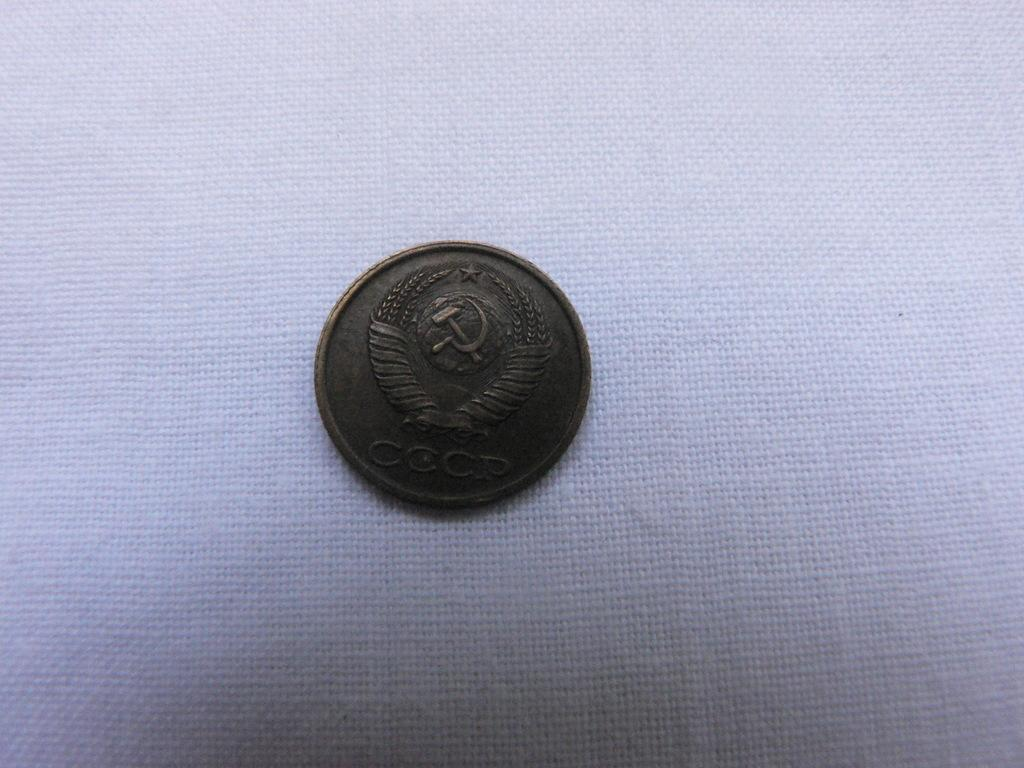<image>
Share a concise interpretation of the image provided. A coin that has a hammer and eagle on it. 